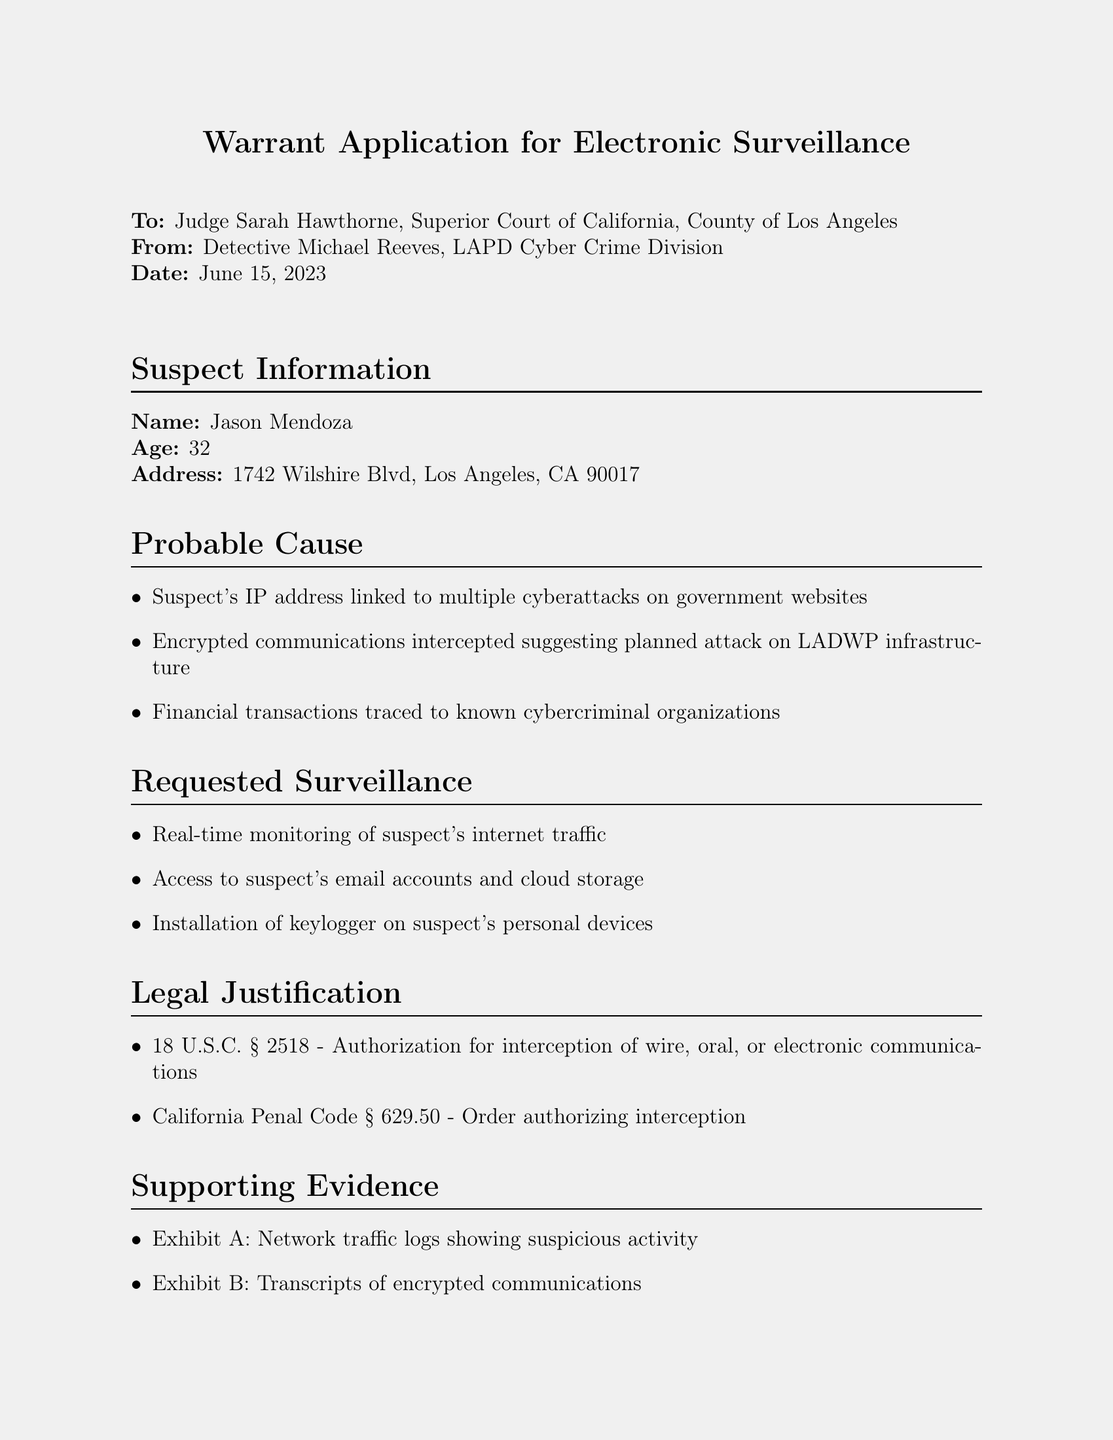What is the name of the suspect? The name of the suspect is clearly stated in the document under "Suspect Information."
Answer: Jason Mendoza What is the suspect's age? The document specifies the age of the suspect in the "Suspect Information" section.
Answer: 32 What is the date of the warrant application? The date is provided at the top of the document, indicating when the warrant application was filed.
Answer: June 15, 2023 What is the first requested surveillance method? The first surveillance method is listed in the "Requested Surveillance" section.
Answer: Real-time monitoring of suspect's internet traffic Which legal code is cited for authorization of interception? The legal justification section references specific legal codes supporting the warrant application.
Answer: 18 U.S.C. § 2518 How many exhibits are listed in the supporting evidence? The supporting evidence section enumerates the exhibits for which supporting documentation is provided.
Answer: 3 What is the urgency statement indicating? The urgency statement summarizes the reasoning for immediate action as outlined in the document.
Answer: Immediate action required to prevent potential critical infrastructure attack and ensure public safety What is the address of the suspect? The suspect's address is provided as part of the "Suspect Information."
Answer: 1742 Wilshire Blvd, Los Angeles, CA 90017 Who is the submitting officer? The document names the officer responsible for the application, providing accountability and contact details.
Answer: Detective Michael Reeves 